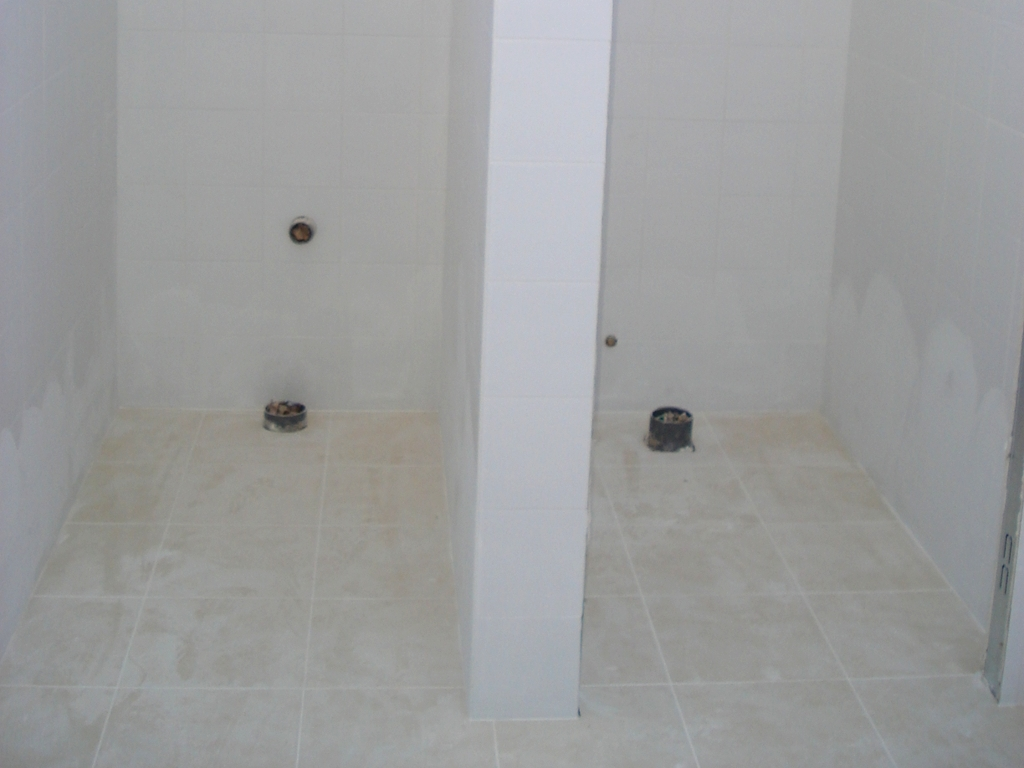What purpose does the central column serve in this space? The central column in the image appears to be a structural element, likely a support pillar crucial for the integrity of the building. Its placement might also suggest a division or separation of the space into different functional areas. 